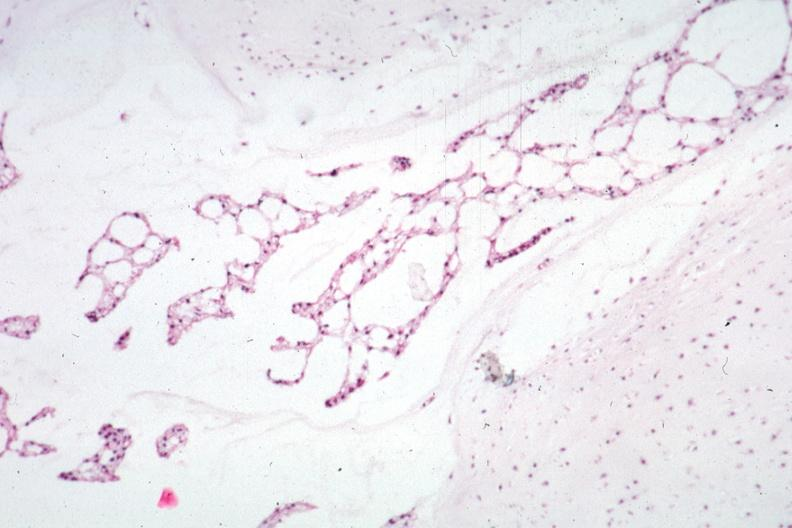what was taken?
Answer the question using a single word or phrase. This section 